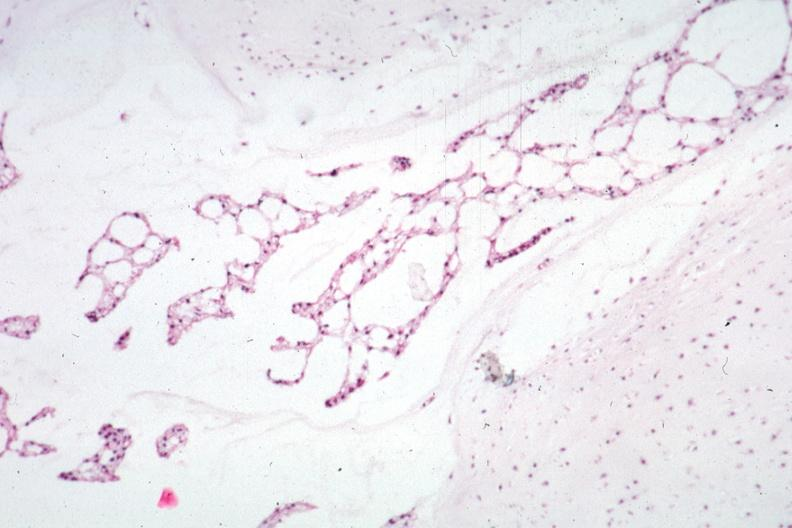what was taken?
Answer the question using a single word or phrase. This section 